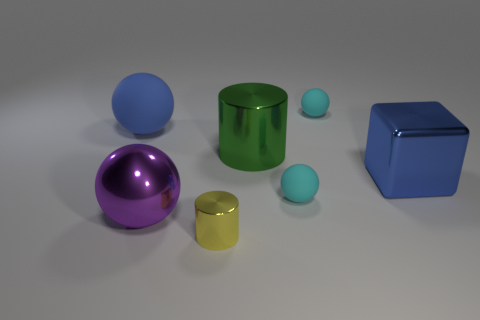Is the color of the metal cube the same as the large rubber thing?
Provide a succinct answer. Yes. What number of shiny cubes are the same color as the big rubber object?
Provide a short and direct response. 1. Do the large block and the matte object that is on the left side of the big metallic cylinder have the same color?
Ensure brevity in your answer.  Yes. There is a big object that is the same color as the large cube; what material is it?
Your answer should be compact. Rubber. How many objects are either large shiny cubes or balls behind the large green thing?
Your answer should be very brief. 3. Is the cyan object that is behind the big green metallic cylinder made of the same material as the large green object?
Provide a succinct answer. No. Is there anything else that has the same size as the blue sphere?
Make the answer very short. Yes. What is the blue object on the left side of the shiny thing in front of the purple object made of?
Provide a short and direct response. Rubber. Is the number of spheres that are in front of the tiny metal cylinder greater than the number of large spheres that are right of the large green shiny object?
Offer a very short reply. No. What is the size of the yellow thing?
Ensure brevity in your answer.  Small. 